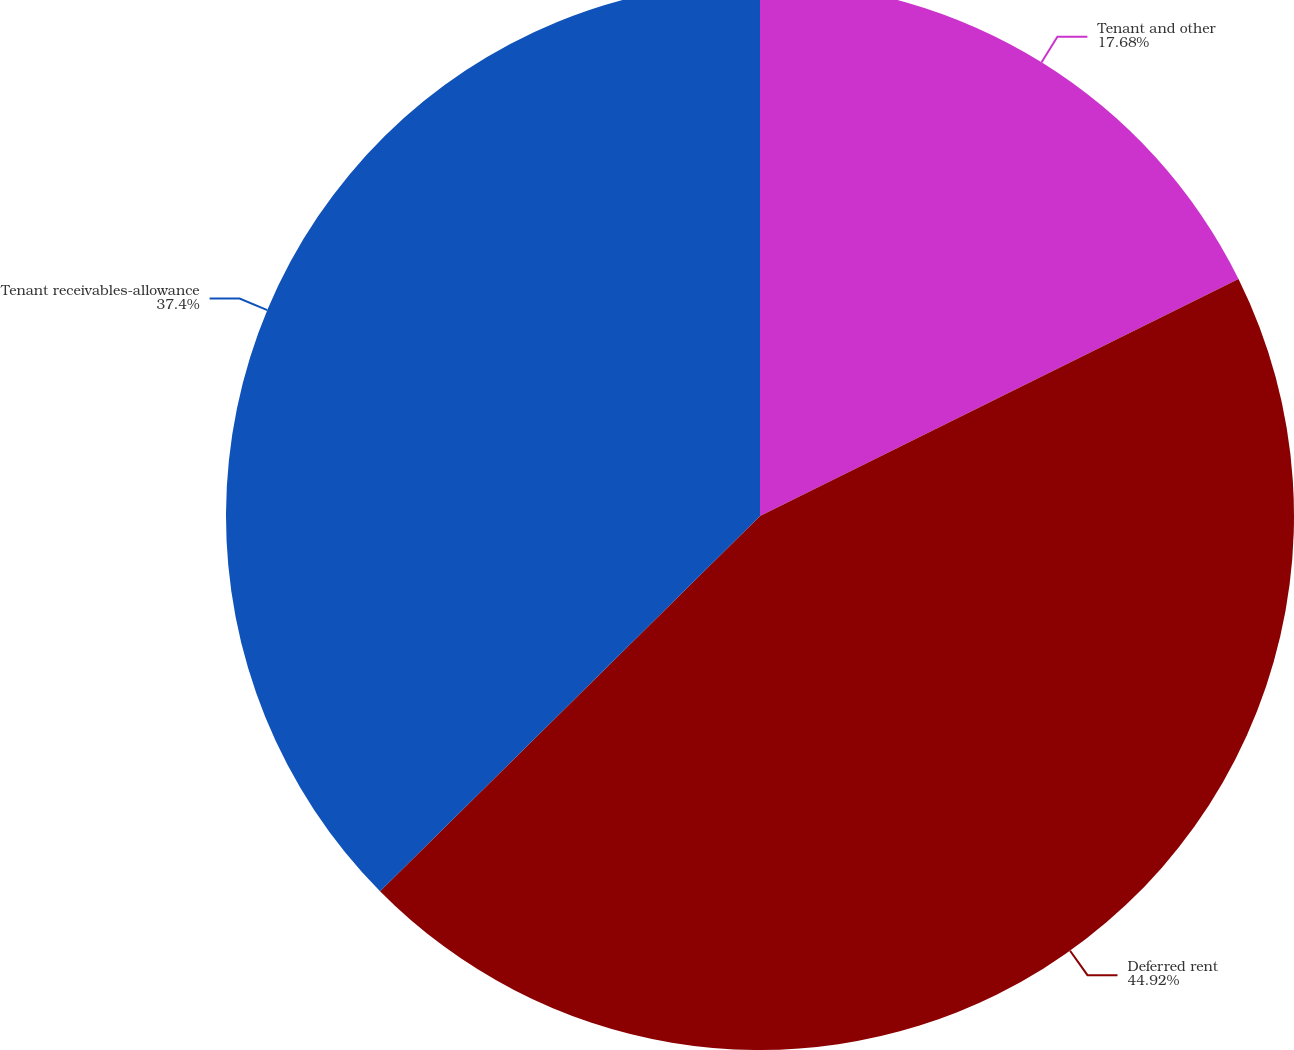Convert chart to OTSL. <chart><loc_0><loc_0><loc_500><loc_500><pie_chart><fcel>Tenant and other<fcel>Deferred rent<fcel>Tenant receivables-allowance<nl><fcel>17.68%<fcel>44.92%<fcel>37.4%<nl></chart> 